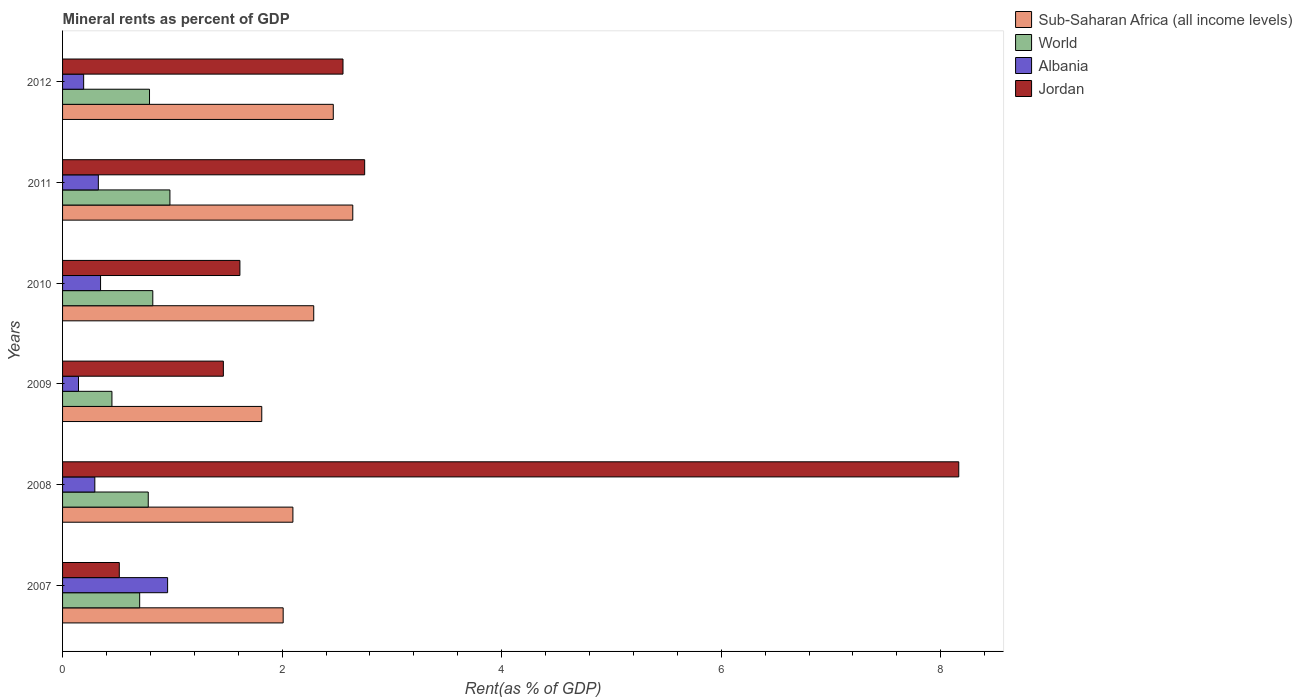How many different coloured bars are there?
Provide a short and direct response. 4. How many groups of bars are there?
Your response must be concise. 6. Are the number of bars per tick equal to the number of legend labels?
Your answer should be very brief. Yes. What is the mineral rent in Jordan in 2007?
Your answer should be compact. 0.52. Across all years, what is the maximum mineral rent in Jordan?
Keep it short and to the point. 8.16. Across all years, what is the minimum mineral rent in Jordan?
Your answer should be compact. 0.52. In which year was the mineral rent in Jordan maximum?
Give a very brief answer. 2008. What is the total mineral rent in World in the graph?
Provide a short and direct response. 4.52. What is the difference between the mineral rent in Albania in 2010 and that in 2012?
Make the answer very short. 0.15. What is the difference between the mineral rent in World in 2010 and the mineral rent in Jordan in 2009?
Your response must be concise. -0.64. What is the average mineral rent in World per year?
Offer a terse response. 0.75. In the year 2012, what is the difference between the mineral rent in World and mineral rent in Sub-Saharan Africa (all income levels)?
Keep it short and to the point. -1.67. In how many years, is the mineral rent in World greater than 2.4 %?
Ensure brevity in your answer.  0. What is the ratio of the mineral rent in World in 2011 to that in 2012?
Your answer should be very brief. 1.23. Is the mineral rent in World in 2008 less than that in 2011?
Offer a terse response. Yes. What is the difference between the highest and the second highest mineral rent in World?
Your answer should be very brief. 0.16. What is the difference between the highest and the lowest mineral rent in World?
Your answer should be very brief. 0.53. In how many years, is the mineral rent in Sub-Saharan Africa (all income levels) greater than the average mineral rent in Sub-Saharan Africa (all income levels) taken over all years?
Your answer should be very brief. 3. What does the 4th bar from the top in 2012 represents?
Your response must be concise. Sub-Saharan Africa (all income levels). What does the 1st bar from the bottom in 2009 represents?
Ensure brevity in your answer.  Sub-Saharan Africa (all income levels). Is it the case that in every year, the sum of the mineral rent in Albania and mineral rent in World is greater than the mineral rent in Jordan?
Your response must be concise. No. Are all the bars in the graph horizontal?
Offer a very short reply. Yes. What is the title of the graph?
Your answer should be compact. Mineral rents as percent of GDP. Does "Oman" appear as one of the legend labels in the graph?
Your response must be concise. No. What is the label or title of the X-axis?
Make the answer very short. Rent(as % of GDP). What is the Rent(as % of GDP) of Sub-Saharan Africa (all income levels) in 2007?
Offer a terse response. 2.01. What is the Rent(as % of GDP) in World in 2007?
Your response must be concise. 0.7. What is the Rent(as % of GDP) of Albania in 2007?
Offer a very short reply. 0.96. What is the Rent(as % of GDP) in Jordan in 2007?
Your response must be concise. 0.52. What is the Rent(as % of GDP) of Sub-Saharan Africa (all income levels) in 2008?
Give a very brief answer. 2.1. What is the Rent(as % of GDP) of World in 2008?
Give a very brief answer. 0.78. What is the Rent(as % of GDP) of Albania in 2008?
Your answer should be compact. 0.29. What is the Rent(as % of GDP) of Jordan in 2008?
Give a very brief answer. 8.16. What is the Rent(as % of GDP) of Sub-Saharan Africa (all income levels) in 2009?
Offer a terse response. 1.81. What is the Rent(as % of GDP) in World in 2009?
Your answer should be very brief. 0.45. What is the Rent(as % of GDP) in Albania in 2009?
Provide a succinct answer. 0.15. What is the Rent(as % of GDP) in Jordan in 2009?
Your answer should be very brief. 1.46. What is the Rent(as % of GDP) of Sub-Saharan Africa (all income levels) in 2010?
Offer a terse response. 2.29. What is the Rent(as % of GDP) of World in 2010?
Ensure brevity in your answer.  0.82. What is the Rent(as % of GDP) of Albania in 2010?
Provide a short and direct response. 0.35. What is the Rent(as % of GDP) of Jordan in 2010?
Your response must be concise. 1.62. What is the Rent(as % of GDP) of Sub-Saharan Africa (all income levels) in 2011?
Make the answer very short. 2.64. What is the Rent(as % of GDP) in World in 2011?
Your answer should be compact. 0.98. What is the Rent(as % of GDP) in Albania in 2011?
Your answer should be very brief. 0.33. What is the Rent(as % of GDP) in Jordan in 2011?
Keep it short and to the point. 2.75. What is the Rent(as % of GDP) of Sub-Saharan Africa (all income levels) in 2012?
Ensure brevity in your answer.  2.47. What is the Rent(as % of GDP) in World in 2012?
Give a very brief answer. 0.79. What is the Rent(as % of GDP) in Albania in 2012?
Provide a short and direct response. 0.19. What is the Rent(as % of GDP) in Jordan in 2012?
Keep it short and to the point. 2.55. Across all years, what is the maximum Rent(as % of GDP) of Sub-Saharan Africa (all income levels)?
Your response must be concise. 2.64. Across all years, what is the maximum Rent(as % of GDP) in World?
Provide a succinct answer. 0.98. Across all years, what is the maximum Rent(as % of GDP) in Albania?
Offer a terse response. 0.96. Across all years, what is the maximum Rent(as % of GDP) in Jordan?
Provide a succinct answer. 8.16. Across all years, what is the minimum Rent(as % of GDP) of Sub-Saharan Africa (all income levels)?
Make the answer very short. 1.81. Across all years, what is the minimum Rent(as % of GDP) of World?
Ensure brevity in your answer.  0.45. Across all years, what is the minimum Rent(as % of GDP) of Albania?
Provide a short and direct response. 0.15. Across all years, what is the minimum Rent(as % of GDP) in Jordan?
Offer a very short reply. 0.52. What is the total Rent(as % of GDP) of Sub-Saharan Africa (all income levels) in the graph?
Give a very brief answer. 13.32. What is the total Rent(as % of GDP) in World in the graph?
Your answer should be very brief. 4.52. What is the total Rent(as % of GDP) in Albania in the graph?
Provide a succinct answer. 2.26. What is the total Rent(as % of GDP) of Jordan in the graph?
Give a very brief answer. 17.07. What is the difference between the Rent(as % of GDP) in Sub-Saharan Africa (all income levels) in 2007 and that in 2008?
Keep it short and to the point. -0.09. What is the difference between the Rent(as % of GDP) of World in 2007 and that in 2008?
Provide a succinct answer. -0.08. What is the difference between the Rent(as % of GDP) of Albania in 2007 and that in 2008?
Your response must be concise. 0.66. What is the difference between the Rent(as % of GDP) of Jordan in 2007 and that in 2008?
Ensure brevity in your answer.  -7.65. What is the difference between the Rent(as % of GDP) in Sub-Saharan Africa (all income levels) in 2007 and that in 2009?
Ensure brevity in your answer.  0.2. What is the difference between the Rent(as % of GDP) in World in 2007 and that in 2009?
Make the answer very short. 0.25. What is the difference between the Rent(as % of GDP) in Albania in 2007 and that in 2009?
Provide a short and direct response. 0.81. What is the difference between the Rent(as % of GDP) in Jordan in 2007 and that in 2009?
Make the answer very short. -0.95. What is the difference between the Rent(as % of GDP) in Sub-Saharan Africa (all income levels) in 2007 and that in 2010?
Offer a terse response. -0.28. What is the difference between the Rent(as % of GDP) in World in 2007 and that in 2010?
Your answer should be compact. -0.12. What is the difference between the Rent(as % of GDP) of Albania in 2007 and that in 2010?
Offer a very short reply. 0.61. What is the difference between the Rent(as % of GDP) of Jordan in 2007 and that in 2010?
Provide a short and direct response. -1.1. What is the difference between the Rent(as % of GDP) in Sub-Saharan Africa (all income levels) in 2007 and that in 2011?
Provide a succinct answer. -0.63. What is the difference between the Rent(as % of GDP) of World in 2007 and that in 2011?
Keep it short and to the point. -0.28. What is the difference between the Rent(as % of GDP) of Albania in 2007 and that in 2011?
Provide a succinct answer. 0.63. What is the difference between the Rent(as % of GDP) in Jordan in 2007 and that in 2011?
Make the answer very short. -2.24. What is the difference between the Rent(as % of GDP) in Sub-Saharan Africa (all income levels) in 2007 and that in 2012?
Provide a succinct answer. -0.46. What is the difference between the Rent(as % of GDP) of World in 2007 and that in 2012?
Provide a succinct answer. -0.09. What is the difference between the Rent(as % of GDP) in Albania in 2007 and that in 2012?
Your response must be concise. 0.76. What is the difference between the Rent(as % of GDP) in Jordan in 2007 and that in 2012?
Offer a very short reply. -2.04. What is the difference between the Rent(as % of GDP) of Sub-Saharan Africa (all income levels) in 2008 and that in 2009?
Give a very brief answer. 0.28. What is the difference between the Rent(as % of GDP) of World in 2008 and that in 2009?
Ensure brevity in your answer.  0.33. What is the difference between the Rent(as % of GDP) of Albania in 2008 and that in 2009?
Offer a terse response. 0.15. What is the difference between the Rent(as % of GDP) in Jordan in 2008 and that in 2009?
Your answer should be compact. 6.7. What is the difference between the Rent(as % of GDP) of Sub-Saharan Africa (all income levels) in 2008 and that in 2010?
Make the answer very short. -0.19. What is the difference between the Rent(as % of GDP) of World in 2008 and that in 2010?
Your response must be concise. -0.04. What is the difference between the Rent(as % of GDP) in Albania in 2008 and that in 2010?
Offer a very short reply. -0.05. What is the difference between the Rent(as % of GDP) of Jordan in 2008 and that in 2010?
Keep it short and to the point. 6.55. What is the difference between the Rent(as % of GDP) in Sub-Saharan Africa (all income levels) in 2008 and that in 2011?
Provide a succinct answer. -0.55. What is the difference between the Rent(as % of GDP) of World in 2008 and that in 2011?
Your answer should be compact. -0.2. What is the difference between the Rent(as % of GDP) in Albania in 2008 and that in 2011?
Ensure brevity in your answer.  -0.03. What is the difference between the Rent(as % of GDP) in Jordan in 2008 and that in 2011?
Keep it short and to the point. 5.41. What is the difference between the Rent(as % of GDP) in Sub-Saharan Africa (all income levels) in 2008 and that in 2012?
Your answer should be very brief. -0.37. What is the difference between the Rent(as % of GDP) in World in 2008 and that in 2012?
Provide a short and direct response. -0.01. What is the difference between the Rent(as % of GDP) of Albania in 2008 and that in 2012?
Ensure brevity in your answer.  0.1. What is the difference between the Rent(as % of GDP) of Jordan in 2008 and that in 2012?
Your answer should be very brief. 5.61. What is the difference between the Rent(as % of GDP) of Sub-Saharan Africa (all income levels) in 2009 and that in 2010?
Offer a very short reply. -0.47. What is the difference between the Rent(as % of GDP) of World in 2009 and that in 2010?
Provide a short and direct response. -0.37. What is the difference between the Rent(as % of GDP) of Albania in 2009 and that in 2010?
Your answer should be compact. -0.2. What is the difference between the Rent(as % of GDP) of Jordan in 2009 and that in 2010?
Provide a short and direct response. -0.15. What is the difference between the Rent(as % of GDP) of Sub-Saharan Africa (all income levels) in 2009 and that in 2011?
Your response must be concise. -0.83. What is the difference between the Rent(as % of GDP) in World in 2009 and that in 2011?
Provide a succinct answer. -0.53. What is the difference between the Rent(as % of GDP) of Albania in 2009 and that in 2011?
Your answer should be very brief. -0.18. What is the difference between the Rent(as % of GDP) in Jordan in 2009 and that in 2011?
Your response must be concise. -1.29. What is the difference between the Rent(as % of GDP) in Sub-Saharan Africa (all income levels) in 2009 and that in 2012?
Make the answer very short. -0.65. What is the difference between the Rent(as % of GDP) of World in 2009 and that in 2012?
Provide a short and direct response. -0.34. What is the difference between the Rent(as % of GDP) in Albania in 2009 and that in 2012?
Offer a terse response. -0.05. What is the difference between the Rent(as % of GDP) in Jordan in 2009 and that in 2012?
Ensure brevity in your answer.  -1.09. What is the difference between the Rent(as % of GDP) in Sub-Saharan Africa (all income levels) in 2010 and that in 2011?
Give a very brief answer. -0.36. What is the difference between the Rent(as % of GDP) of World in 2010 and that in 2011?
Give a very brief answer. -0.16. What is the difference between the Rent(as % of GDP) of Albania in 2010 and that in 2011?
Make the answer very short. 0.02. What is the difference between the Rent(as % of GDP) in Jordan in 2010 and that in 2011?
Provide a short and direct response. -1.14. What is the difference between the Rent(as % of GDP) of Sub-Saharan Africa (all income levels) in 2010 and that in 2012?
Ensure brevity in your answer.  -0.18. What is the difference between the Rent(as % of GDP) in World in 2010 and that in 2012?
Your answer should be very brief. 0.03. What is the difference between the Rent(as % of GDP) of Albania in 2010 and that in 2012?
Your answer should be compact. 0.15. What is the difference between the Rent(as % of GDP) in Jordan in 2010 and that in 2012?
Provide a short and direct response. -0.94. What is the difference between the Rent(as % of GDP) in Sub-Saharan Africa (all income levels) in 2011 and that in 2012?
Your response must be concise. 0.18. What is the difference between the Rent(as % of GDP) of World in 2011 and that in 2012?
Offer a terse response. 0.19. What is the difference between the Rent(as % of GDP) in Albania in 2011 and that in 2012?
Keep it short and to the point. 0.13. What is the difference between the Rent(as % of GDP) of Jordan in 2011 and that in 2012?
Your answer should be compact. 0.2. What is the difference between the Rent(as % of GDP) in Sub-Saharan Africa (all income levels) in 2007 and the Rent(as % of GDP) in World in 2008?
Make the answer very short. 1.23. What is the difference between the Rent(as % of GDP) of Sub-Saharan Africa (all income levels) in 2007 and the Rent(as % of GDP) of Albania in 2008?
Ensure brevity in your answer.  1.72. What is the difference between the Rent(as % of GDP) in Sub-Saharan Africa (all income levels) in 2007 and the Rent(as % of GDP) in Jordan in 2008?
Your answer should be compact. -6.15. What is the difference between the Rent(as % of GDP) of World in 2007 and the Rent(as % of GDP) of Albania in 2008?
Offer a very short reply. 0.41. What is the difference between the Rent(as % of GDP) of World in 2007 and the Rent(as % of GDP) of Jordan in 2008?
Ensure brevity in your answer.  -7.46. What is the difference between the Rent(as % of GDP) of Albania in 2007 and the Rent(as % of GDP) of Jordan in 2008?
Offer a terse response. -7.21. What is the difference between the Rent(as % of GDP) of Sub-Saharan Africa (all income levels) in 2007 and the Rent(as % of GDP) of World in 2009?
Your response must be concise. 1.56. What is the difference between the Rent(as % of GDP) in Sub-Saharan Africa (all income levels) in 2007 and the Rent(as % of GDP) in Albania in 2009?
Offer a very short reply. 1.86. What is the difference between the Rent(as % of GDP) of Sub-Saharan Africa (all income levels) in 2007 and the Rent(as % of GDP) of Jordan in 2009?
Offer a terse response. 0.54. What is the difference between the Rent(as % of GDP) of World in 2007 and the Rent(as % of GDP) of Albania in 2009?
Offer a terse response. 0.56. What is the difference between the Rent(as % of GDP) in World in 2007 and the Rent(as % of GDP) in Jordan in 2009?
Your answer should be compact. -0.76. What is the difference between the Rent(as % of GDP) in Albania in 2007 and the Rent(as % of GDP) in Jordan in 2009?
Make the answer very short. -0.51. What is the difference between the Rent(as % of GDP) of Sub-Saharan Africa (all income levels) in 2007 and the Rent(as % of GDP) of World in 2010?
Your answer should be very brief. 1.19. What is the difference between the Rent(as % of GDP) in Sub-Saharan Africa (all income levels) in 2007 and the Rent(as % of GDP) in Albania in 2010?
Your answer should be very brief. 1.66. What is the difference between the Rent(as % of GDP) of Sub-Saharan Africa (all income levels) in 2007 and the Rent(as % of GDP) of Jordan in 2010?
Offer a very short reply. 0.39. What is the difference between the Rent(as % of GDP) of World in 2007 and the Rent(as % of GDP) of Albania in 2010?
Make the answer very short. 0.36. What is the difference between the Rent(as % of GDP) in World in 2007 and the Rent(as % of GDP) in Jordan in 2010?
Give a very brief answer. -0.91. What is the difference between the Rent(as % of GDP) of Albania in 2007 and the Rent(as % of GDP) of Jordan in 2010?
Keep it short and to the point. -0.66. What is the difference between the Rent(as % of GDP) in Sub-Saharan Africa (all income levels) in 2007 and the Rent(as % of GDP) in World in 2011?
Keep it short and to the point. 1.03. What is the difference between the Rent(as % of GDP) in Sub-Saharan Africa (all income levels) in 2007 and the Rent(as % of GDP) in Albania in 2011?
Your answer should be very brief. 1.68. What is the difference between the Rent(as % of GDP) in Sub-Saharan Africa (all income levels) in 2007 and the Rent(as % of GDP) in Jordan in 2011?
Provide a short and direct response. -0.74. What is the difference between the Rent(as % of GDP) of World in 2007 and the Rent(as % of GDP) of Albania in 2011?
Offer a very short reply. 0.38. What is the difference between the Rent(as % of GDP) of World in 2007 and the Rent(as % of GDP) of Jordan in 2011?
Give a very brief answer. -2.05. What is the difference between the Rent(as % of GDP) of Albania in 2007 and the Rent(as % of GDP) of Jordan in 2011?
Provide a succinct answer. -1.8. What is the difference between the Rent(as % of GDP) of Sub-Saharan Africa (all income levels) in 2007 and the Rent(as % of GDP) of World in 2012?
Keep it short and to the point. 1.22. What is the difference between the Rent(as % of GDP) of Sub-Saharan Africa (all income levels) in 2007 and the Rent(as % of GDP) of Albania in 2012?
Provide a short and direct response. 1.82. What is the difference between the Rent(as % of GDP) of Sub-Saharan Africa (all income levels) in 2007 and the Rent(as % of GDP) of Jordan in 2012?
Your response must be concise. -0.55. What is the difference between the Rent(as % of GDP) in World in 2007 and the Rent(as % of GDP) in Albania in 2012?
Your answer should be very brief. 0.51. What is the difference between the Rent(as % of GDP) in World in 2007 and the Rent(as % of GDP) in Jordan in 2012?
Keep it short and to the point. -1.85. What is the difference between the Rent(as % of GDP) of Albania in 2007 and the Rent(as % of GDP) of Jordan in 2012?
Make the answer very short. -1.6. What is the difference between the Rent(as % of GDP) of Sub-Saharan Africa (all income levels) in 2008 and the Rent(as % of GDP) of World in 2009?
Make the answer very short. 1.65. What is the difference between the Rent(as % of GDP) of Sub-Saharan Africa (all income levels) in 2008 and the Rent(as % of GDP) of Albania in 2009?
Your response must be concise. 1.95. What is the difference between the Rent(as % of GDP) in Sub-Saharan Africa (all income levels) in 2008 and the Rent(as % of GDP) in Jordan in 2009?
Provide a short and direct response. 0.63. What is the difference between the Rent(as % of GDP) of World in 2008 and the Rent(as % of GDP) of Albania in 2009?
Make the answer very short. 0.64. What is the difference between the Rent(as % of GDP) of World in 2008 and the Rent(as % of GDP) of Jordan in 2009?
Your response must be concise. -0.68. What is the difference between the Rent(as % of GDP) in Albania in 2008 and the Rent(as % of GDP) in Jordan in 2009?
Ensure brevity in your answer.  -1.17. What is the difference between the Rent(as % of GDP) in Sub-Saharan Africa (all income levels) in 2008 and the Rent(as % of GDP) in World in 2010?
Make the answer very short. 1.28. What is the difference between the Rent(as % of GDP) in Sub-Saharan Africa (all income levels) in 2008 and the Rent(as % of GDP) in Albania in 2010?
Your answer should be compact. 1.75. What is the difference between the Rent(as % of GDP) in Sub-Saharan Africa (all income levels) in 2008 and the Rent(as % of GDP) in Jordan in 2010?
Ensure brevity in your answer.  0.48. What is the difference between the Rent(as % of GDP) in World in 2008 and the Rent(as % of GDP) in Albania in 2010?
Keep it short and to the point. 0.43. What is the difference between the Rent(as % of GDP) in World in 2008 and the Rent(as % of GDP) in Jordan in 2010?
Keep it short and to the point. -0.83. What is the difference between the Rent(as % of GDP) in Albania in 2008 and the Rent(as % of GDP) in Jordan in 2010?
Offer a very short reply. -1.32. What is the difference between the Rent(as % of GDP) in Sub-Saharan Africa (all income levels) in 2008 and the Rent(as % of GDP) in World in 2011?
Your answer should be very brief. 1.12. What is the difference between the Rent(as % of GDP) in Sub-Saharan Africa (all income levels) in 2008 and the Rent(as % of GDP) in Albania in 2011?
Your answer should be compact. 1.77. What is the difference between the Rent(as % of GDP) of Sub-Saharan Africa (all income levels) in 2008 and the Rent(as % of GDP) of Jordan in 2011?
Your answer should be compact. -0.65. What is the difference between the Rent(as % of GDP) of World in 2008 and the Rent(as % of GDP) of Albania in 2011?
Give a very brief answer. 0.45. What is the difference between the Rent(as % of GDP) of World in 2008 and the Rent(as % of GDP) of Jordan in 2011?
Make the answer very short. -1.97. What is the difference between the Rent(as % of GDP) of Albania in 2008 and the Rent(as % of GDP) of Jordan in 2011?
Offer a terse response. -2.46. What is the difference between the Rent(as % of GDP) in Sub-Saharan Africa (all income levels) in 2008 and the Rent(as % of GDP) in World in 2012?
Your response must be concise. 1.31. What is the difference between the Rent(as % of GDP) in Sub-Saharan Africa (all income levels) in 2008 and the Rent(as % of GDP) in Albania in 2012?
Your answer should be compact. 1.91. What is the difference between the Rent(as % of GDP) in Sub-Saharan Africa (all income levels) in 2008 and the Rent(as % of GDP) in Jordan in 2012?
Keep it short and to the point. -0.46. What is the difference between the Rent(as % of GDP) in World in 2008 and the Rent(as % of GDP) in Albania in 2012?
Your response must be concise. 0.59. What is the difference between the Rent(as % of GDP) of World in 2008 and the Rent(as % of GDP) of Jordan in 2012?
Offer a terse response. -1.77. What is the difference between the Rent(as % of GDP) of Albania in 2008 and the Rent(as % of GDP) of Jordan in 2012?
Offer a very short reply. -2.26. What is the difference between the Rent(as % of GDP) of Sub-Saharan Africa (all income levels) in 2009 and the Rent(as % of GDP) of Albania in 2010?
Make the answer very short. 1.47. What is the difference between the Rent(as % of GDP) of Sub-Saharan Africa (all income levels) in 2009 and the Rent(as % of GDP) of Jordan in 2010?
Provide a succinct answer. 0.2. What is the difference between the Rent(as % of GDP) of World in 2009 and the Rent(as % of GDP) of Albania in 2010?
Offer a terse response. 0.1. What is the difference between the Rent(as % of GDP) of World in 2009 and the Rent(as % of GDP) of Jordan in 2010?
Make the answer very short. -1.17. What is the difference between the Rent(as % of GDP) in Albania in 2009 and the Rent(as % of GDP) in Jordan in 2010?
Offer a terse response. -1.47. What is the difference between the Rent(as % of GDP) of Sub-Saharan Africa (all income levels) in 2009 and the Rent(as % of GDP) of World in 2011?
Make the answer very short. 0.84. What is the difference between the Rent(as % of GDP) of Sub-Saharan Africa (all income levels) in 2009 and the Rent(as % of GDP) of Albania in 2011?
Your answer should be compact. 1.49. What is the difference between the Rent(as % of GDP) in Sub-Saharan Africa (all income levels) in 2009 and the Rent(as % of GDP) in Jordan in 2011?
Provide a succinct answer. -0.94. What is the difference between the Rent(as % of GDP) of World in 2009 and the Rent(as % of GDP) of Albania in 2011?
Make the answer very short. 0.12. What is the difference between the Rent(as % of GDP) in World in 2009 and the Rent(as % of GDP) in Jordan in 2011?
Give a very brief answer. -2.3. What is the difference between the Rent(as % of GDP) in Albania in 2009 and the Rent(as % of GDP) in Jordan in 2011?
Provide a succinct answer. -2.61. What is the difference between the Rent(as % of GDP) in Sub-Saharan Africa (all income levels) in 2009 and the Rent(as % of GDP) in World in 2012?
Your response must be concise. 1.02. What is the difference between the Rent(as % of GDP) in Sub-Saharan Africa (all income levels) in 2009 and the Rent(as % of GDP) in Albania in 2012?
Your answer should be very brief. 1.62. What is the difference between the Rent(as % of GDP) of Sub-Saharan Africa (all income levels) in 2009 and the Rent(as % of GDP) of Jordan in 2012?
Your answer should be compact. -0.74. What is the difference between the Rent(as % of GDP) in World in 2009 and the Rent(as % of GDP) in Albania in 2012?
Provide a succinct answer. 0.26. What is the difference between the Rent(as % of GDP) of World in 2009 and the Rent(as % of GDP) of Jordan in 2012?
Keep it short and to the point. -2.1. What is the difference between the Rent(as % of GDP) of Albania in 2009 and the Rent(as % of GDP) of Jordan in 2012?
Offer a very short reply. -2.41. What is the difference between the Rent(as % of GDP) in Sub-Saharan Africa (all income levels) in 2010 and the Rent(as % of GDP) in World in 2011?
Your answer should be very brief. 1.31. What is the difference between the Rent(as % of GDP) of Sub-Saharan Africa (all income levels) in 2010 and the Rent(as % of GDP) of Albania in 2011?
Make the answer very short. 1.96. What is the difference between the Rent(as % of GDP) of Sub-Saharan Africa (all income levels) in 2010 and the Rent(as % of GDP) of Jordan in 2011?
Keep it short and to the point. -0.46. What is the difference between the Rent(as % of GDP) in World in 2010 and the Rent(as % of GDP) in Albania in 2011?
Your answer should be very brief. 0.5. What is the difference between the Rent(as % of GDP) in World in 2010 and the Rent(as % of GDP) in Jordan in 2011?
Provide a succinct answer. -1.93. What is the difference between the Rent(as % of GDP) of Albania in 2010 and the Rent(as % of GDP) of Jordan in 2011?
Provide a short and direct response. -2.41. What is the difference between the Rent(as % of GDP) of Sub-Saharan Africa (all income levels) in 2010 and the Rent(as % of GDP) of World in 2012?
Offer a very short reply. 1.5. What is the difference between the Rent(as % of GDP) in Sub-Saharan Africa (all income levels) in 2010 and the Rent(as % of GDP) in Albania in 2012?
Offer a terse response. 2.1. What is the difference between the Rent(as % of GDP) in Sub-Saharan Africa (all income levels) in 2010 and the Rent(as % of GDP) in Jordan in 2012?
Offer a terse response. -0.27. What is the difference between the Rent(as % of GDP) in World in 2010 and the Rent(as % of GDP) in Albania in 2012?
Offer a very short reply. 0.63. What is the difference between the Rent(as % of GDP) in World in 2010 and the Rent(as % of GDP) in Jordan in 2012?
Offer a terse response. -1.73. What is the difference between the Rent(as % of GDP) of Albania in 2010 and the Rent(as % of GDP) of Jordan in 2012?
Your answer should be compact. -2.21. What is the difference between the Rent(as % of GDP) of Sub-Saharan Africa (all income levels) in 2011 and the Rent(as % of GDP) of World in 2012?
Your response must be concise. 1.85. What is the difference between the Rent(as % of GDP) of Sub-Saharan Africa (all income levels) in 2011 and the Rent(as % of GDP) of Albania in 2012?
Offer a terse response. 2.45. What is the difference between the Rent(as % of GDP) in Sub-Saharan Africa (all income levels) in 2011 and the Rent(as % of GDP) in Jordan in 2012?
Provide a succinct answer. 0.09. What is the difference between the Rent(as % of GDP) of World in 2011 and the Rent(as % of GDP) of Albania in 2012?
Your response must be concise. 0.79. What is the difference between the Rent(as % of GDP) of World in 2011 and the Rent(as % of GDP) of Jordan in 2012?
Keep it short and to the point. -1.58. What is the difference between the Rent(as % of GDP) in Albania in 2011 and the Rent(as % of GDP) in Jordan in 2012?
Keep it short and to the point. -2.23. What is the average Rent(as % of GDP) of Sub-Saharan Africa (all income levels) per year?
Offer a very short reply. 2.22. What is the average Rent(as % of GDP) of World per year?
Ensure brevity in your answer.  0.75. What is the average Rent(as % of GDP) in Albania per year?
Offer a terse response. 0.38. What is the average Rent(as % of GDP) of Jordan per year?
Your answer should be compact. 2.84. In the year 2007, what is the difference between the Rent(as % of GDP) of Sub-Saharan Africa (all income levels) and Rent(as % of GDP) of World?
Provide a succinct answer. 1.31. In the year 2007, what is the difference between the Rent(as % of GDP) of Sub-Saharan Africa (all income levels) and Rent(as % of GDP) of Albania?
Give a very brief answer. 1.05. In the year 2007, what is the difference between the Rent(as % of GDP) of Sub-Saharan Africa (all income levels) and Rent(as % of GDP) of Jordan?
Keep it short and to the point. 1.49. In the year 2007, what is the difference between the Rent(as % of GDP) of World and Rent(as % of GDP) of Albania?
Provide a short and direct response. -0.25. In the year 2007, what is the difference between the Rent(as % of GDP) in World and Rent(as % of GDP) in Jordan?
Make the answer very short. 0.19. In the year 2007, what is the difference between the Rent(as % of GDP) in Albania and Rent(as % of GDP) in Jordan?
Make the answer very short. 0.44. In the year 2008, what is the difference between the Rent(as % of GDP) in Sub-Saharan Africa (all income levels) and Rent(as % of GDP) in World?
Keep it short and to the point. 1.32. In the year 2008, what is the difference between the Rent(as % of GDP) in Sub-Saharan Africa (all income levels) and Rent(as % of GDP) in Albania?
Offer a terse response. 1.8. In the year 2008, what is the difference between the Rent(as % of GDP) in Sub-Saharan Africa (all income levels) and Rent(as % of GDP) in Jordan?
Provide a short and direct response. -6.07. In the year 2008, what is the difference between the Rent(as % of GDP) in World and Rent(as % of GDP) in Albania?
Give a very brief answer. 0.49. In the year 2008, what is the difference between the Rent(as % of GDP) of World and Rent(as % of GDP) of Jordan?
Give a very brief answer. -7.38. In the year 2008, what is the difference between the Rent(as % of GDP) of Albania and Rent(as % of GDP) of Jordan?
Ensure brevity in your answer.  -7.87. In the year 2009, what is the difference between the Rent(as % of GDP) of Sub-Saharan Africa (all income levels) and Rent(as % of GDP) of World?
Give a very brief answer. 1.36. In the year 2009, what is the difference between the Rent(as % of GDP) of Sub-Saharan Africa (all income levels) and Rent(as % of GDP) of Albania?
Give a very brief answer. 1.67. In the year 2009, what is the difference between the Rent(as % of GDP) of Sub-Saharan Africa (all income levels) and Rent(as % of GDP) of Jordan?
Make the answer very short. 0.35. In the year 2009, what is the difference between the Rent(as % of GDP) of World and Rent(as % of GDP) of Albania?
Provide a succinct answer. 0.3. In the year 2009, what is the difference between the Rent(as % of GDP) of World and Rent(as % of GDP) of Jordan?
Offer a very short reply. -1.01. In the year 2009, what is the difference between the Rent(as % of GDP) of Albania and Rent(as % of GDP) of Jordan?
Provide a short and direct response. -1.32. In the year 2010, what is the difference between the Rent(as % of GDP) of Sub-Saharan Africa (all income levels) and Rent(as % of GDP) of World?
Offer a very short reply. 1.47. In the year 2010, what is the difference between the Rent(as % of GDP) in Sub-Saharan Africa (all income levels) and Rent(as % of GDP) in Albania?
Offer a terse response. 1.94. In the year 2010, what is the difference between the Rent(as % of GDP) in Sub-Saharan Africa (all income levels) and Rent(as % of GDP) in Jordan?
Provide a short and direct response. 0.67. In the year 2010, what is the difference between the Rent(as % of GDP) in World and Rent(as % of GDP) in Albania?
Make the answer very short. 0.48. In the year 2010, what is the difference between the Rent(as % of GDP) in World and Rent(as % of GDP) in Jordan?
Keep it short and to the point. -0.79. In the year 2010, what is the difference between the Rent(as % of GDP) in Albania and Rent(as % of GDP) in Jordan?
Provide a succinct answer. -1.27. In the year 2011, what is the difference between the Rent(as % of GDP) of Sub-Saharan Africa (all income levels) and Rent(as % of GDP) of World?
Provide a succinct answer. 1.67. In the year 2011, what is the difference between the Rent(as % of GDP) of Sub-Saharan Africa (all income levels) and Rent(as % of GDP) of Albania?
Provide a short and direct response. 2.32. In the year 2011, what is the difference between the Rent(as % of GDP) of Sub-Saharan Africa (all income levels) and Rent(as % of GDP) of Jordan?
Your answer should be very brief. -0.11. In the year 2011, what is the difference between the Rent(as % of GDP) in World and Rent(as % of GDP) in Albania?
Your answer should be compact. 0.65. In the year 2011, what is the difference between the Rent(as % of GDP) of World and Rent(as % of GDP) of Jordan?
Make the answer very short. -1.77. In the year 2011, what is the difference between the Rent(as % of GDP) of Albania and Rent(as % of GDP) of Jordan?
Offer a terse response. -2.43. In the year 2012, what is the difference between the Rent(as % of GDP) of Sub-Saharan Africa (all income levels) and Rent(as % of GDP) of World?
Provide a short and direct response. 1.67. In the year 2012, what is the difference between the Rent(as % of GDP) in Sub-Saharan Africa (all income levels) and Rent(as % of GDP) in Albania?
Your answer should be compact. 2.27. In the year 2012, what is the difference between the Rent(as % of GDP) in Sub-Saharan Africa (all income levels) and Rent(as % of GDP) in Jordan?
Keep it short and to the point. -0.09. In the year 2012, what is the difference between the Rent(as % of GDP) of World and Rent(as % of GDP) of Albania?
Your response must be concise. 0.6. In the year 2012, what is the difference between the Rent(as % of GDP) in World and Rent(as % of GDP) in Jordan?
Provide a succinct answer. -1.76. In the year 2012, what is the difference between the Rent(as % of GDP) in Albania and Rent(as % of GDP) in Jordan?
Offer a very short reply. -2.36. What is the ratio of the Rent(as % of GDP) of Sub-Saharan Africa (all income levels) in 2007 to that in 2008?
Your response must be concise. 0.96. What is the ratio of the Rent(as % of GDP) of World in 2007 to that in 2008?
Give a very brief answer. 0.9. What is the ratio of the Rent(as % of GDP) of Albania in 2007 to that in 2008?
Offer a terse response. 3.26. What is the ratio of the Rent(as % of GDP) of Jordan in 2007 to that in 2008?
Provide a succinct answer. 0.06. What is the ratio of the Rent(as % of GDP) in Sub-Saharan Africa (all income levels) in 2007 to that in 2009?
Your answer should be very brief. 1.11. What is the ratio of the Rent(as % of GDP) of World in 2007 to that in 2009?
Your response must be concise. 1.56. What is the ratio of the Rent(as % of GDP) of Albania in 2007 to that in 2009?
Make the answer very short. 6.59. What is the ratio of the Rent(as % of GDP) in Jordan in 2007 to that in 2009?
Ensure brevity in your answer.  0.35. What is the ratio of the Rent(as % of GDP) in Sub-Saharan Africa (all income levels) in 2007 to that in 2010?
Your response must be concise. 0.88. What is the ratio of the Rent(as % of GDP) of World in 2007 to that in 2010?
Offer a terse response. 0.85. What is the ratio of the Rent(as % of GDP) in Albania in 2007 to that in 2010?
Keep it short and to the point. 2.76. What is the ratio of the Rent(as % of GDP) in Jordan in 2007 to that in 2010?
Your response must be concise. 0.32. What is the ratio of the Rent(as % of GDP) of Sub-Saharan Africa (all income levels) in 2007 to that in 2011?
Ensure brevity in your answer.  0.76. What is the ratio of the Rent(as % of GDP) in World in 2007 to that in 2011?
Keep it short and to the point. 0.72. What is the ratio of the Rent(as % of GDP) of Albania in 2007 to that in 2011?
Offer a terse response. 2.94. What is the ratio of the Rent(as % of GDP) of Jordan in 2007 to that in 2011?
Ensure brevity in your answer.  0.19. What is the ratio of the Rent(as % of GDP) in Sub-Saharan Africa (all income levels) in 2007 to that in 2012?
Give a very brief answer. 0.81. What is the ratio of the Rent(as % of GDP) of World in 2007 to that in 2012?
Keep it short and to the point. 0.89. What is the ratio of the Rent(as % of GDP) in Albania in 2007 to that in 2012?
Your answer should be very brief. 4.98. What is the ratio of the Rent(as % of GDP) in Jordan in 2007 to that in 2012?
Offer a very short reply. 0.2. What is the ratio of the Rent(as % of GDP) of Sub-Saharan Africa (all income levels) in 2008 to that in 2009?
Your answer should be very brief. 1.16. What is the ratio of the Rent(as % of GDP) in World in 2008 to that in 2009?
Offer a terse response. 1.74. What is the ratio of the Rent(as % of GDP) in Albania in 2008 to that in 2009?
Offer a terse response. 2.02. What is the ratio of the Rent(as % of GDP) of Jordan in 2008 to that in 2009?
Offer a terse response. 5.57. What is the ratio of the Rent(as % of GDP) in Sub-Saharan Africa (all income levels) in 2008 to that in 2010?
Give a very brief answer. 0.92. What is the ratio of the Rent(as % of GDP) of World in 2008 to that in 2010?
Give a very brief answer. 0.95. What is the ratio of the Rent(as % of GDP) in Albania in 2008 to that in 2010?
Keep it short and to the point. 0.85. What is the ratio of the Rent(as % of GDP) of Jordan in 2008 to that in 2010?
Offer a terse response. 5.05. What is the ratio of the Rent(as % of GDP) in Sub-Saharan Africa (all income levels) in 2008 to that in 2011?
Offer a very short reply. 0.79. What is the ratio of the Rent(as % of GDP) in World in 2008 to that in 2011?
Provide a short and direct response. 0.8. What is the ratio of the Rent(as % of GDP) of Albania in 2008 to that in 2011?
Keep it short and to the point. 0.9. What is the ratio of the Rent(as % of GDP) in Jordan in 2008 to that in 2011?
Your answer should be very brief. 2.97. What is the ratio of the Rent(as % of GDP) of Sub-Saharan Africa (all income levels) in 2008 to that in 2012?
Ensure brevity in your answer.  0.85. What is the ratio of the Rent(as % of GDP) of World in 2008 to that in 2012?
Your answer should be compact. 0.99. What is the ratio of the Rent(as % of GDP) in Albania in 2008 to that in 2012?
Offer a very short reply. 1.53. What is the ratio of the Rent(as % of GDP) in Jordan in 2008 to that in 2012?
Ensure brevity in your answer.  3.2. What is the ratio of the Rent(as % of GDP) in Sub-Saharan Africa (all income levels) in 2009 to that in 2010?
Provide a short and direct response. 0.79. What is the ratio of the Rent(as % of GDP) of World in 2009 to that in 2010?
Offer a terse response. 0.55. What is the ratio of the Rent(as % of GDP) in Albania in 2009 to that in 2010?
Provide a succinct answer. 0.42. What is the ratio of the Rent(as % of GDP) in Jordan in 2009 to that in 2010?
Keep it short and to the point. 0.91. What is the ratio of the Rent(as % of GDP) in Sub-Saharan Africa (all income levels) in 2009 to that in 2011?
Your answer should be very brief. 0.69. What is the ratio of the Rent(as % of GDP) in World in 2009 to that in 2011?
Your response must be concise. 0.46. What is the ratio of the Rent(as % of GDP) of Albania in 2009 to that in 2011?
Your answer should be very brief. 0.45. What is the ratio of the Rent(as % of GDP) in Jordan in 2009 to that in 2011?
Your answer should be compact. 0.53. What is the ratio of the Rent(as % of GDP) of Sub-Saharan Africa (all income levels) in 2009 to that in 2012?
Provide a short and direct response. 0.74. What is the ratio of the Rent(as % of GDP) of World in 2009 to that in 2012?
Provide a succinct answer. 0.57. What is the ratio of the Rent(as % of GDP) in Albania in 2009 to that in 2012?
Keep it short and to the point. 0.76. What is the ratio of the Rent(as % of GDP) in Jordan in 2009 to that in 2012?
Give a very brief answer. 0.57. What is the ratio of the Rent(as % of GDP) in Sub-Saharan Africa (all income levels) in 2010 to that in 2011?
Keep it short and to the point. 0.87. What is the ratio of the Rent(as % of GDP) of World in 2010 to that in 2011?
Provide a succinct answer. 0.84. What is the ratio of the Rent(as % of GDP) of Albania in 2010 to that in 2011?
Your response must be concise. 1.06. What is the ratio of the Rent(as % of GDP) of Jordan in 2010 to that in 2011?
Offer a terse response. 0.59. What is the ratio of the Rent(as % of GDP) of Sub-Saharan Africa (all income levels) in 2010 to that in 2012?
Offer a terse response. 0.93. What is the ratio of the Rent(as % of GDP) in World in 2010 to that in 2012?
Make the answer very short. 1.04. What is the ratio of the Rent(as % of GDP) in Albania in 2010 to that in 2012?
Provide a short and direct response. 1.8. What is the ratio of the Rent(as % of GDP) in Jordan in 2010 to that in 2012?
Your response must be concise. 0.63. What is the ratio of the Rent(as % of GDP) in Sub-Saharan Africa (all income levels) in 2011 to that in 2012?
Your answer should be compact. 1.07. What is the ratio of the Rent(as % of GDP) of World in 2011 to that in 2012?
Ensure brevity in your answer.  1.23. What is the ratio of the Rent(as % of GDP) of Albania in 2011 to that in 2012?
Give a very brief answer. 1.7. What is the ratio of the Rent(as % of GDP) in Jordan in 2011 to that in 2012?
Give a very brief answer. 1.08. What is the difference between the highest and the second highest Rent(as % of GDP) of Sub-Saharan Africa (all income levels)?
Offer a terse response. 0.18. What is the difference between the highest and the second highest Rent(as % of GDP) in World?
Ensure brevity in your answer.  0.16. What is the difference between the highest and the second highest Rent(as % of GDP) of Albania?
Provide a succinct answer. 0.61. What is the difference between the highest and the second highest Rent(as % of GDP) in Jordan?
Your answer should be very brief. 5.41. What is the difference between the highest and the lowest Rent(as % of GDP) in Sub-Saharan Africa (all income levels)?
Provide a succinct answer. 0.83. What is the difference between the highest and the lowest Rent(as % of GDP) in World?
Ensure brevity in your answer.  0.53. What is the difference between the highest and the lowest Rent(as % of GDP) in Albania?
Your response must be concise. 0.81. What is the difference between the highest and the lowest Rent(as % of GDP) in Jordan?
Your response must be concise. 7.65. 